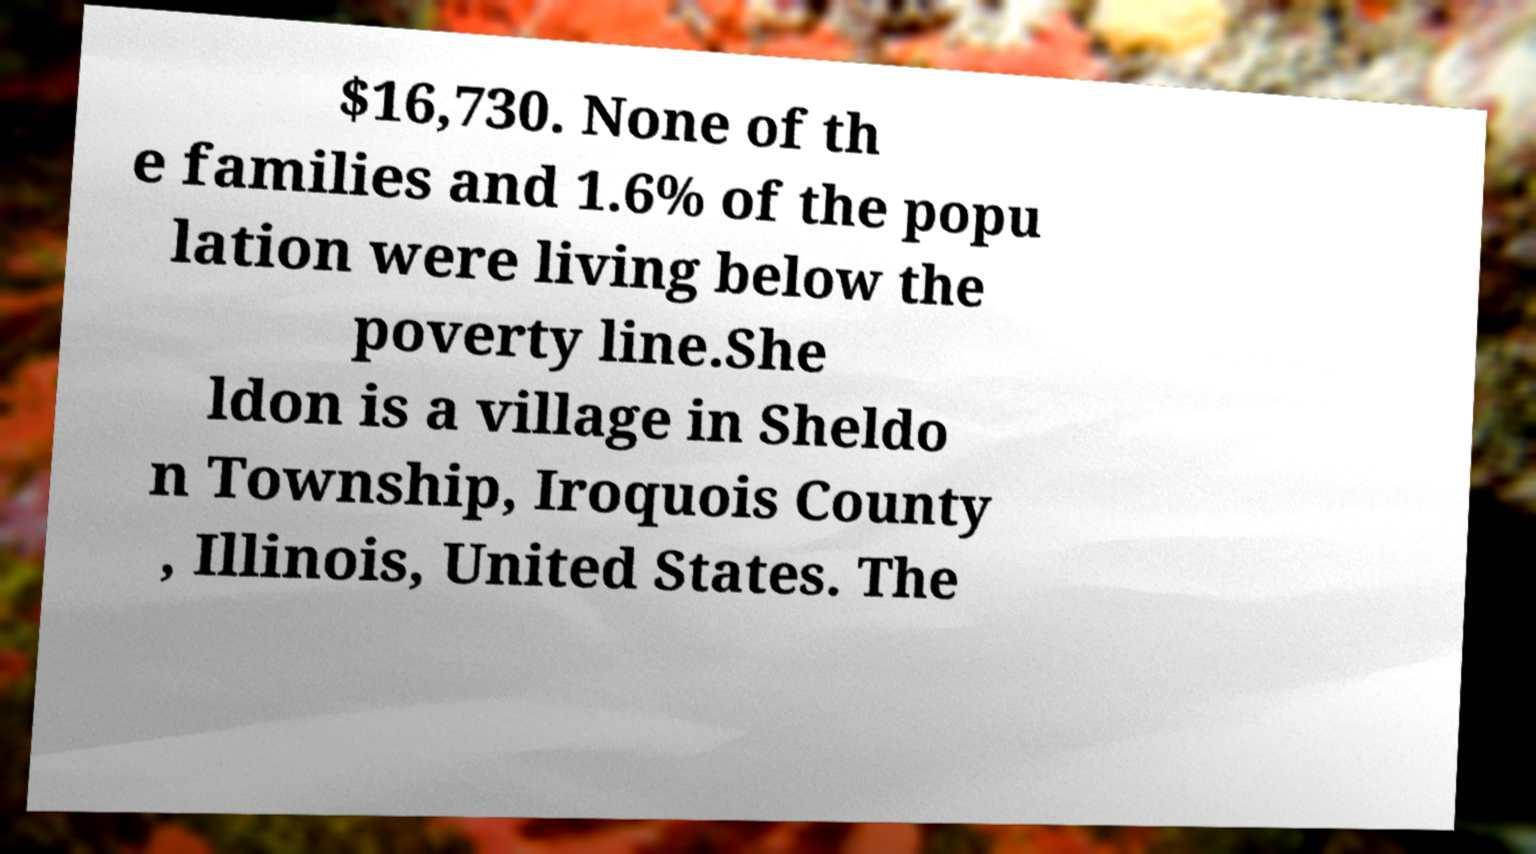I need the written content from this picture converted into text. Can you do that? $16,730. None of th e families and 1.6% of the popu lation were living below the poverty line.She ldon is a village in Sheldo n Township, Iroquois County , Illinois, United States. The 